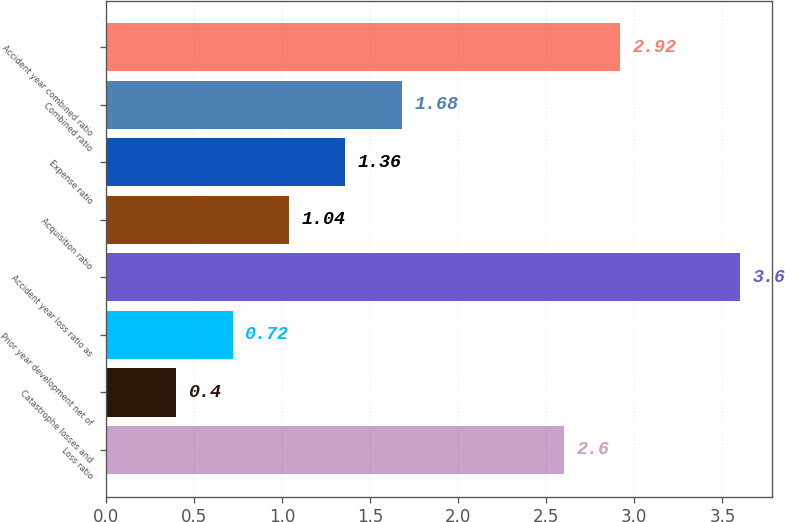Convert chart to OTSL. <chart><loc_0><loc_0><loc_500><loc_500><bar_chart><fcel>Loss ratio<fcel>Catastrophe losses and<fcel>Prior year development net of<fcel>Accident year loss ratio as<fcel>Acquisition ratio<fcel>Expense ratio<fcel>Combined ratio<fcel>Accident year combined ratio<nl><fcel>2.6<fcel>0.4<fcel>0.72<fcel>3.6<fcel>1.04<fcel>1.36<fcel>1.68<fcel>2.92<nl></chart> 